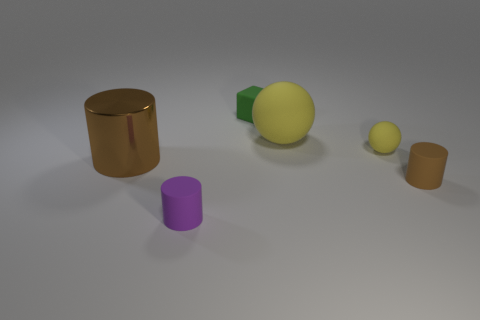Add 3 tiny red matte cylinders. How many objects exist? 9 Subtract all balls. How many objects are left? 4 Add 6 small matte cylinders. How many small matte cylinders are left? 8 Add 2 large brown shiny cylinders. How many large brown shiny cylinders exist? 3 Subtract 0 gray cylinders. How many objects are left? 6 Subtract all big brown shiny spheres. Subtract all large brown metallic cylinders. How many objects are left? 5 